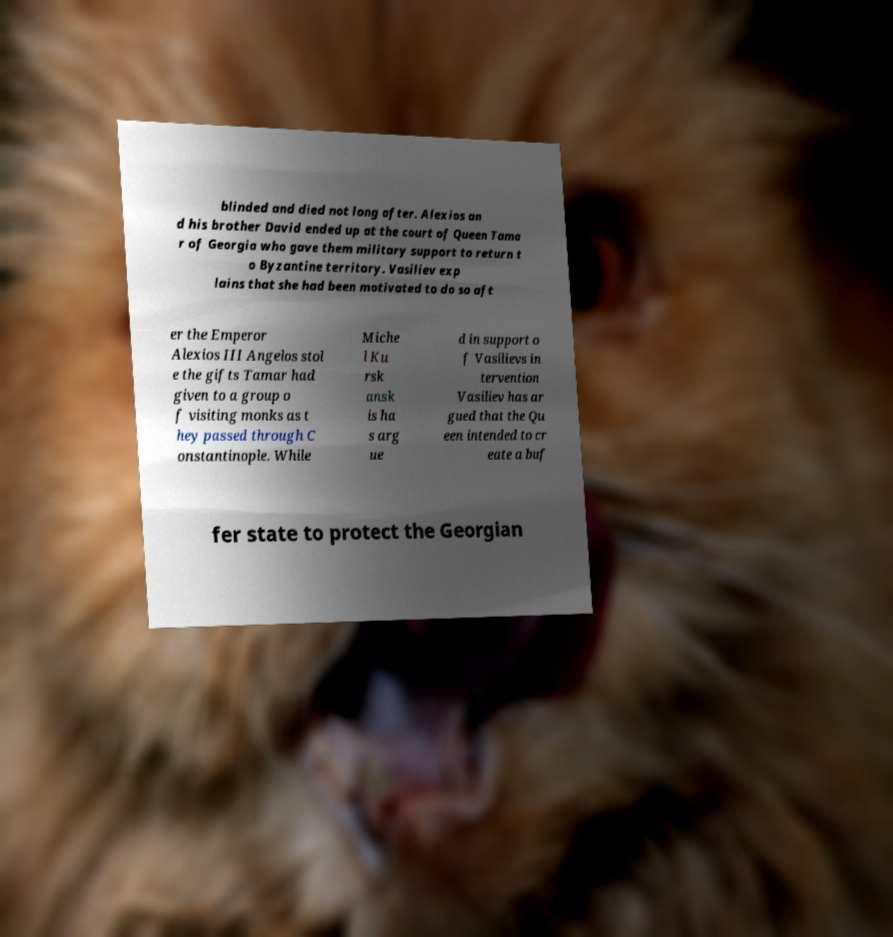Can you read and provide the text displayed in the image?This photo seems to have some interesting text. Can you extract and type it out for me? blinded and died not long after. Alexios an d his brother David ended up at the court of Queen Tama r of Georgia who gave them military support to return t o Byzantine territory. Vasiliev exp lains that she had been motivated to do so aft er the Emperor Alexios III Angelos stol e the gifts Tamar had given to a group o f visiting monks as t hey passed through C onstantinople. While Miche l Ku rsk ansk is ha s arg ue d in support o f Vasilievs in tervention Vasiliev has ar gued that the Qu een intended to cr eate a buf fer state to protect the Georgian 